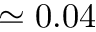<formula> <loc_0><loc_0><loc_500><loc_500>\simeq 0 . 0 4</formula> 